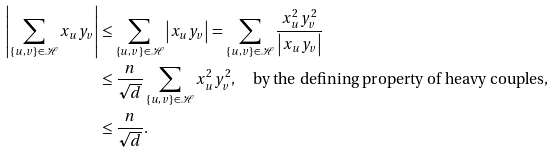Convert formula to latex. <formula><loc_0><loc_0><loc_500><loc_500>\left | \sum _ { \{ u , v \} \in \mathcal { H } } x _ { u } y _ { v } \right | & \leq \sum _ { \{ u , v \} \in \mathcal { H } } \left | x _ { u } y _ { v } \right | = \sum _ { \{ u , v \} \in \mathcal { H } } \frac { x _ { u } ^ { 2 } y _ { v } ^ { 2 } } { \left | x _ { u } y _ { v } \right | } \\ & \leq \frac { n } { \sqrt { d } } \sum _ { \{ u , v \} \in \mathcal { H } } { x _ { u } ^ { 2 } y _ { v } ^ { 2 } } , \quad \text {by the defining property of heavy couples,} \\ & \leq \frac { n } { \sqrt { d } } .</formula> 